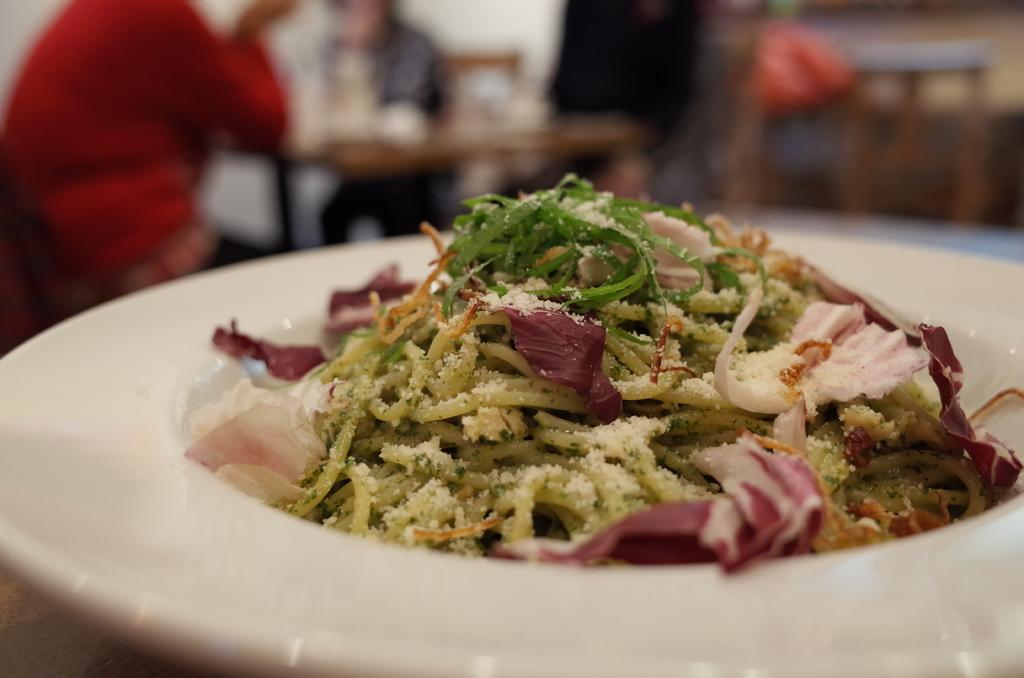What is located in the foreground of the image? There is a plate in the foreground of the image. What is on the plate? There is food on the plate. How would you describe the background of the image? The background of the image is blurry. Can you describe the people in the background? Two people are sitting in the background. What else can be seen in the background? There are tables in the background. What type of cat is sitting on the table in the image? There is no cat present in the image. What achievements have the people in the image accomplished? The image does not provide information about the achievements of the people in the background. 